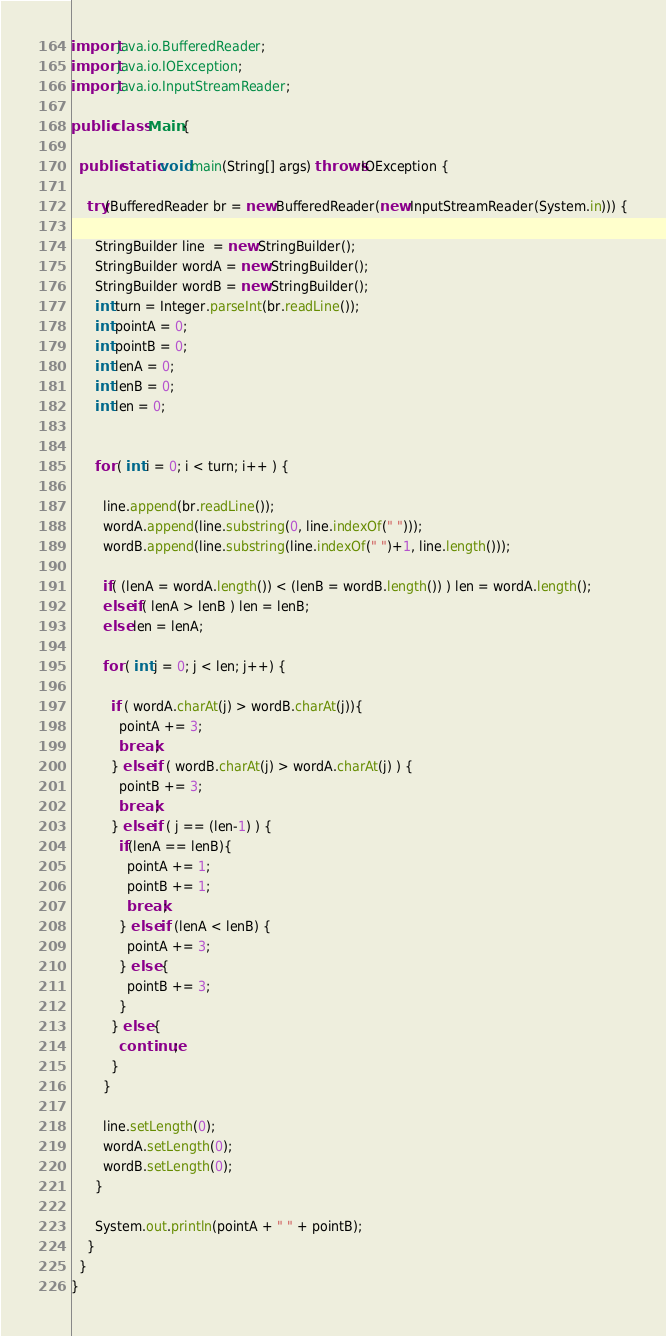<code> <loc_0><loc_0><loc_500><loc_500><_Java_>import java.io.BufferedReader;
import java.io.IOException;
import java.io.InputStreamReader;

public class Main {

  public static void main(String[] args) throws IOException {
    
    try(BufferedReader br = new BufferedReader(new InputStreamReader(System.in))) {

      StringBuilder line  = new StringBuilder();
      StringBuilder wordA = new StringBuilder();
      StringBuilder wordB = new StringBuilder();
      int turn = Integer.parseInt(br.readLine());
      int pointA = 0;
      int pointB = 0;
      int lenA = 0;
      int lenB = 0;
      int len = 0;


      for ( int i = 0; i < turn; i++ ) {

        line.append(br.readLine());
        wordA.append(line.substring(0, line.indexOf(" ")));
        wordB.append(line.substring(line.indexOf(" ")+1, line.length()));

        if( (lenA = wordA.length()) < (lenB = wordB.length()) ) len = wordA.length();
        else if( lenA > lenB ) len = lenB;
        else len = lenA;

        for ( int j = 0; j < len; j++) {

          if ( wordA.charAt(j) > wordB.charAt(j)){
            pointA += 3;
            break;
          } else if ( wordB.charAt(j) > wordA.charAt(j) ) {
            pointB += 3;
            break;
          } else if ( j == (len-1) ) {
            if(lenA == lenB){
              pointA += 1;
              pointB += 1;
              break;
            } else if (lenA < lenB) {
              pointA += 3;
            } else {
              pointB += 3;
            }
          } else {
            continue;
          }
        }

        line.setLength(0);
        wordA.setLength(0);
        wordB.setLength(0);
      }

      System.out.println(pointA + " " + pointB);
    }
  }
}
</code> 